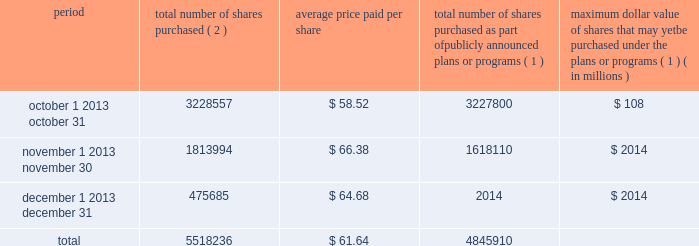Issuer purchases of equity securities the table provides information regarding purchases of our common stock that were made by us during the fourth quarter of 2011 .
Period total number of shares purchased ( 2 ) average price paid per share total number of shares purchased as part of publicly announced plans or programs ( 1 ) maximum dollar value of shares that may yet be purchased under the plans or programs ( 1 ) ( in millions ) .
( 1 ) in may 2010 , our board of directors approved a $ 3.5 billion share repurchase program .
We completed this program in the fourth quarter of 2011 .
In total , we repurchased 49.2 million common shares for $ 3.5 billion , or $ 71.18 per share , under this program .
( 2 ) during the fourth quarter of 2011 , we repurchased 672326 shares from company employees for the payment of personal income tax withholdings resulting from restricted stock vesting and stock option exercises .
Such repurchases are in addition to the $ 3.5 billion repurchase program .
Under the devon energy corporation incentive savings plan ( the 201cplan 201d ) , eligible employees may purchase shares of our common stock through an investment in the devon stock fund ( the 201cstock fund 201d ) , which is administered by an independent trustee , fidelity management trust company .
Eligible employees purchased approximately 45000 shares of our common stock in 2011 , at then-prevailing stock prices , that they held through their ownership in the stock fund .
We acquired the shares of our common stock sold under the plan through open-market purchases .
We filed a registration statement on form s-8 on january 26 , 2012 registering any offers and sales of interests in the plan or the stock fund and of the underlying shares of our common stock purchased by plan participants after that date .
Similarly , under the devon canada corporation savings plan ( the 201ccanadian plan 201d ) , eligible canadian employees may purchase shares of our common stock through an investment in the canadian plan , which is administered by an independent trustee , sun life assurance company of canada .
Eligible canadian employees purchased approximately 9000 shares of our common stock in 2011 , at then-prevailing stock prices , that they held through their ownership in the canadian plan .
We acquired the shares sold under the canadian plan through open-market purchases .
These shares and any interest in the canadian plan were offered and sold in reliance on the exemptions for offers and sales of securities made outside of the u.s. , including under regulation s for offers and sales of securities to employees pursuant to an employee benefit plan established and administered in accordance with the law of a country other than the u.s. .
What percentage of total shares repurchased were purchased in october? 
Computations: (3228557 / 5518236)
Answer: 0.58507. 